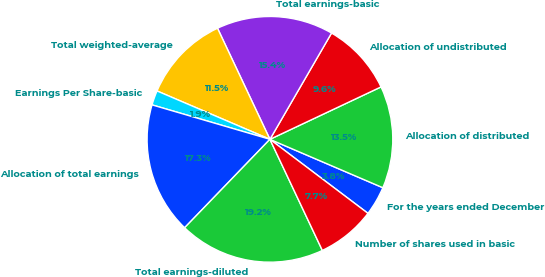Convert chart to OTSL. <chart><loc_0><loc_0><loc_500><loc_500><pie_chart><fcel>For the years ended December<fcel>Allocation of distributed<fcel>Allocation of undistributed<fcel>Total earnings-basic<fcel>Total weighted-average<fcel>Earnings Per Share-basic<fcel>Allocation of total earnings<fcel>Total earnings-diluted<fcel>Number of shares used in basic<nl><fcel>3.85%<fcel>13.46%<fcel>9.62%<fcel>15.38%<fcel>11.54%<fcel>1.92%<fcel>17.31%<fcel>19.23%<fcel>7.69%<nl></chart> 